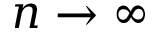Convert formula to latex. <formula><loc_0><loc_0><loc_500><loc_500>n \rightarrow \infty</formula> 